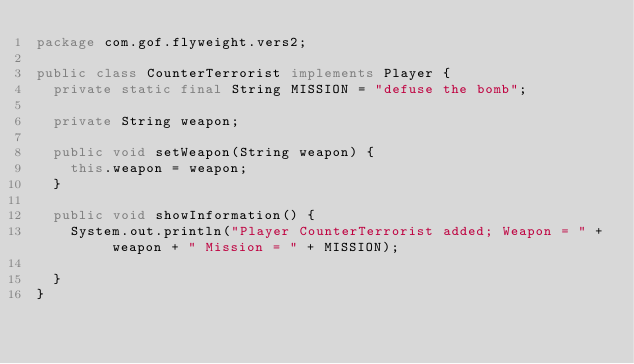Convert code to text. <code><loc_0><loc_0><loc_500><loc_500><_Java_>package com.gof.flyweight.vers2;

public class CounterTerrorist implements Player {
  private static final String MISSION = "defuse the bomb";

  private String weapon;

  public void setWeapon(String weapon) {
    this.weapon = weapon;
  }

  public void showInformation() {
    System.out.println("Player CounterTerrorist added; Weapon = " + weapon + " Mission = " + MISSION);

  }
}
</code> 